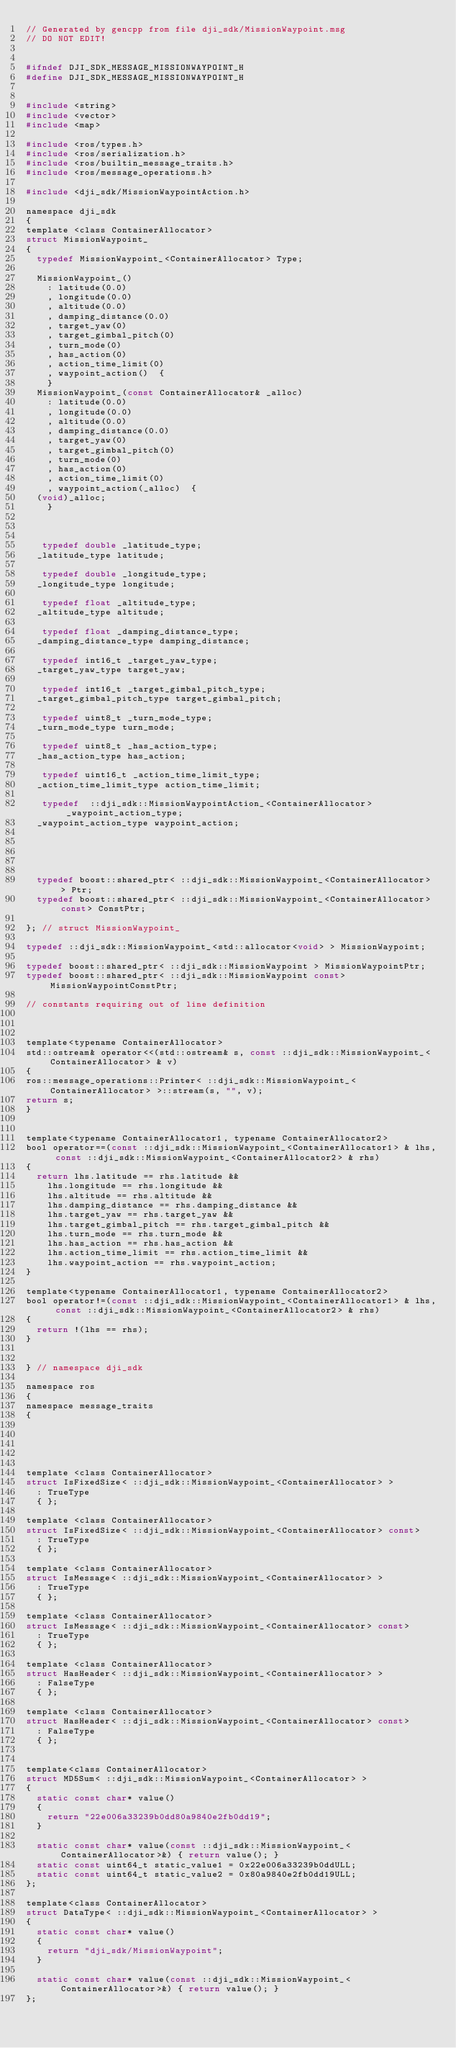Convert code to text. <code><loc_0><loc_0><loc_500><loc_500><_C_>// Generated by gencpp from file dji_sdk/MissionWaypoint.msg
// DO NOT EDIT!


#ifndef DJI_SDK_MESSAGE_MISSIONWAYPOINT_H
#define DJI_SDK_MESSAGE_MISSIONWAYPOINT_H


#include <string>
#include <vector>
#include <map>

#include <ros/types.h>
#include <ros/serialization.h>
#include <ros/builtin_message_traits.h>
#include <ros/message_operations.h>

#include <dji_sdk/MissionWaypointAction.h>

namespace dji_sdk
{
template <class ContainerAllocator>
struct MissionWaypoint_
{
  typedef MissionWaypoint_<ContainerAllocator> Type;

  MissionWaypoint_()
    : latitude(0.0)
    , longitude(0.0)
    , altitude(0.0)
    , damping_distance(0.0)
    , target_yaw(0)
    , target_gimbal_pitch(0)
    , turn_mode(0)
    , has_action(0)
    , action_time_limit(0)
    , waypoint_action()  {
    }
  MissionWaypoint_(const ContainerAllocator& _alloc)
    : latitude(0.0)
    , longitude(0.0)
    , altitude(0.0)
    , damping_distance(0.0)
    , target_yaw(0)
    , target_gimbal_pitch(0)
    , turn_mode(0)
    , has_action(0)
    , action_time_limit(0)
    , waypoint_action(_alloc)  {
  (void)_alloc;
    }



   typedef double _latitude_type;
  _latitude_type latitude;

   typedef double _longitude_type;
  _longitude_type longitude;

   typedef float _altitude_type;
  _altitude_type altitude;

   typedef float _damping_distance_type;
  _damping_distance_type damping_distance;

   typedef int16_t _target_yaw_type;
  _target_yaw_type target_yaw;

   typedef int16_t _target_gimbal_pitch_type;
  _target_gimbal_pitch_type target_gimbal_pitch;

   typedef uint8_t _turn_mode_type;
  _turn_mode_type turn_mode;

   typedef uint8_t _has_action_type;
  _has_action_type has_action;

   typedef uint16_t _action_time_limit_type;
  _action_time_limit_type action_time_limit;

   typedef  ::dji_sdk::MissionWaypointAction_<ContainerAllocator>  _waypoint_action_type;
  _waypoint_action_type waypoint_action;





  typedef boost::shared_ptr< ::dji_sdk::MissionWaypoint_<ContainerAllocator> > Ptr;
  typedef boost::shared_ptr< ::dji_sdk::MissionWaypoint_<ContainerAllocator> const> ConstPtr;

}; // struct MissionWaypoint_

typedef ::dji_sdk::MissionWaypoint_<std::allocator<void> > MissionWaypoint;

typedef boost::shared_ptr< ::dji_sdk::MissionWaypoint > MissionWaypointPtr;
typedef boost::shared_ptr< ::dji_sdk::MissionWaypoint const> MissionWaypointConstPtr;

// constants requiring out of line definition



template<typename ContainerAllocator>
std::ostream& operator<<(std::ostream& s, const ::dji_sdk::MissionWaypoint_<ContainerAllocator> & v)
{
ros::message_operations::Printer< ::dji_sdk::MissionWaypoint_<ContainerAllocator> >::stream(s, "", v);
return s;
}


template<typename ContainerAllocator1, typename ContainerAllocator2>
bool operator==(const ::dji_sdk::MissionWaypoint_<ContainerAllocator1> & lhs, const ::dji_sdk::MissionWaypoint_<ContainerAllocator2> & rhs)
{
  return lhs.latitude == rhs.latitude &&
    lhs.longitude == rhs.longitude &&
    lhs.altitude == rhs.altitude &&
    lhs.damping_distance == rhs.damping_distance &&
    lhs.target_yaw == rhs.target_yaw &&
    lhs.target_gimbal_pitch == rhs.target_gimbal_pitch &&
    lhs.turn_mode == rhs.turn_mode &&
    lhs.has_action == rhs.has_action &&
    lhs.action_time_limit == rhs.action_time_limit &&
    lhs.waypoint_action == rhs.waypoint_action;
}

template<typename ContainerAllocator1, typename ContainerAllocator2>
bool operator!=(const ::dji_sdk::MissionWaypoint_<ContainerAllocator1> & lhs, const ::dji_sdk::MissionWaypoint_<ContainerAllocator2> & rhs)
{
  return !(lhs == rhs);
}


} // namespace dji_sdk

namespace ros
{
namespace message_traits
{





template <class ContainerAllocator>
struct IsFixedSize< ::dji_sdk::MissionWaypoint_<ContainerAllocator> >
  : TrueType
  { };

template <class ContainerAllocator>
struct IsFixedSize< ::dji_sdk::MissionWaypoint_<ContainerAllocator> const>
  : TrueType
  { };

template <class ContainerAllocator>
struct IsMessage< ::dji_sdk::MissionWaypoint_<ContainerAllocator> >
  : TrueType
  { };

template <class ContainerAllocator>
struct IsMessage< ::dji_sdk::MissionWaypoint_<ContainerAllocator> const>
  : TrueType
  { };

template <class ContainerAllocator>
struct HasHeader< ::dji_sdk::MissionWaypoint_<ContainerAllocator> >
  : FalseType
  { };

template <class ContainerAllocator>
struct HasHeader< ::dji_sdk::MissionWaypoint_<ContainerAllocator> const>
  : FalseType
  { };


template<class ContainerAllocator>
struct MD5Sum< ::dji_sdk::MissionWaypoint_<ContainerAllocator> >
{
  static const char* value()
  {
    return "22e006a33239b0dd80a9840e2fb0dd19";
  }

  static const char* value(const ::dji_sdk::MissionWaypoint_<ContainerAllocator>&) { return value(); }
  static const uint64_t static_value1 = 0x22e006a33239b0ddULL;
  static const uint64_t static_value2 = 0x80a9840e2fb0dd19ULL;
};

template<class ContainerAllocator>
struct DataType< ::dji_sdk::MissionWaypoint_<ContainerAllocator> >
{
  static const char* value()
  {
    return "dji_sdk/MissionWaypoint";
  }

  static const char* value(const ::dji_sdk::MissionWaypoint_<ContainerAllocator>&) { return value(); }
};
</code> 